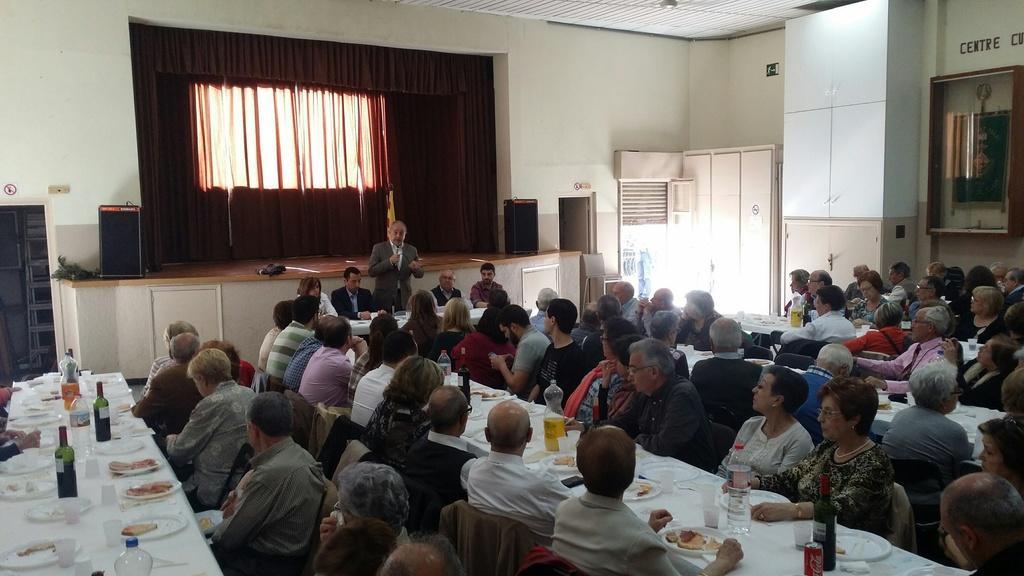Can you describe this image briefly? Group of people sitting at tables are listening to a man whose is standing and speaking. 